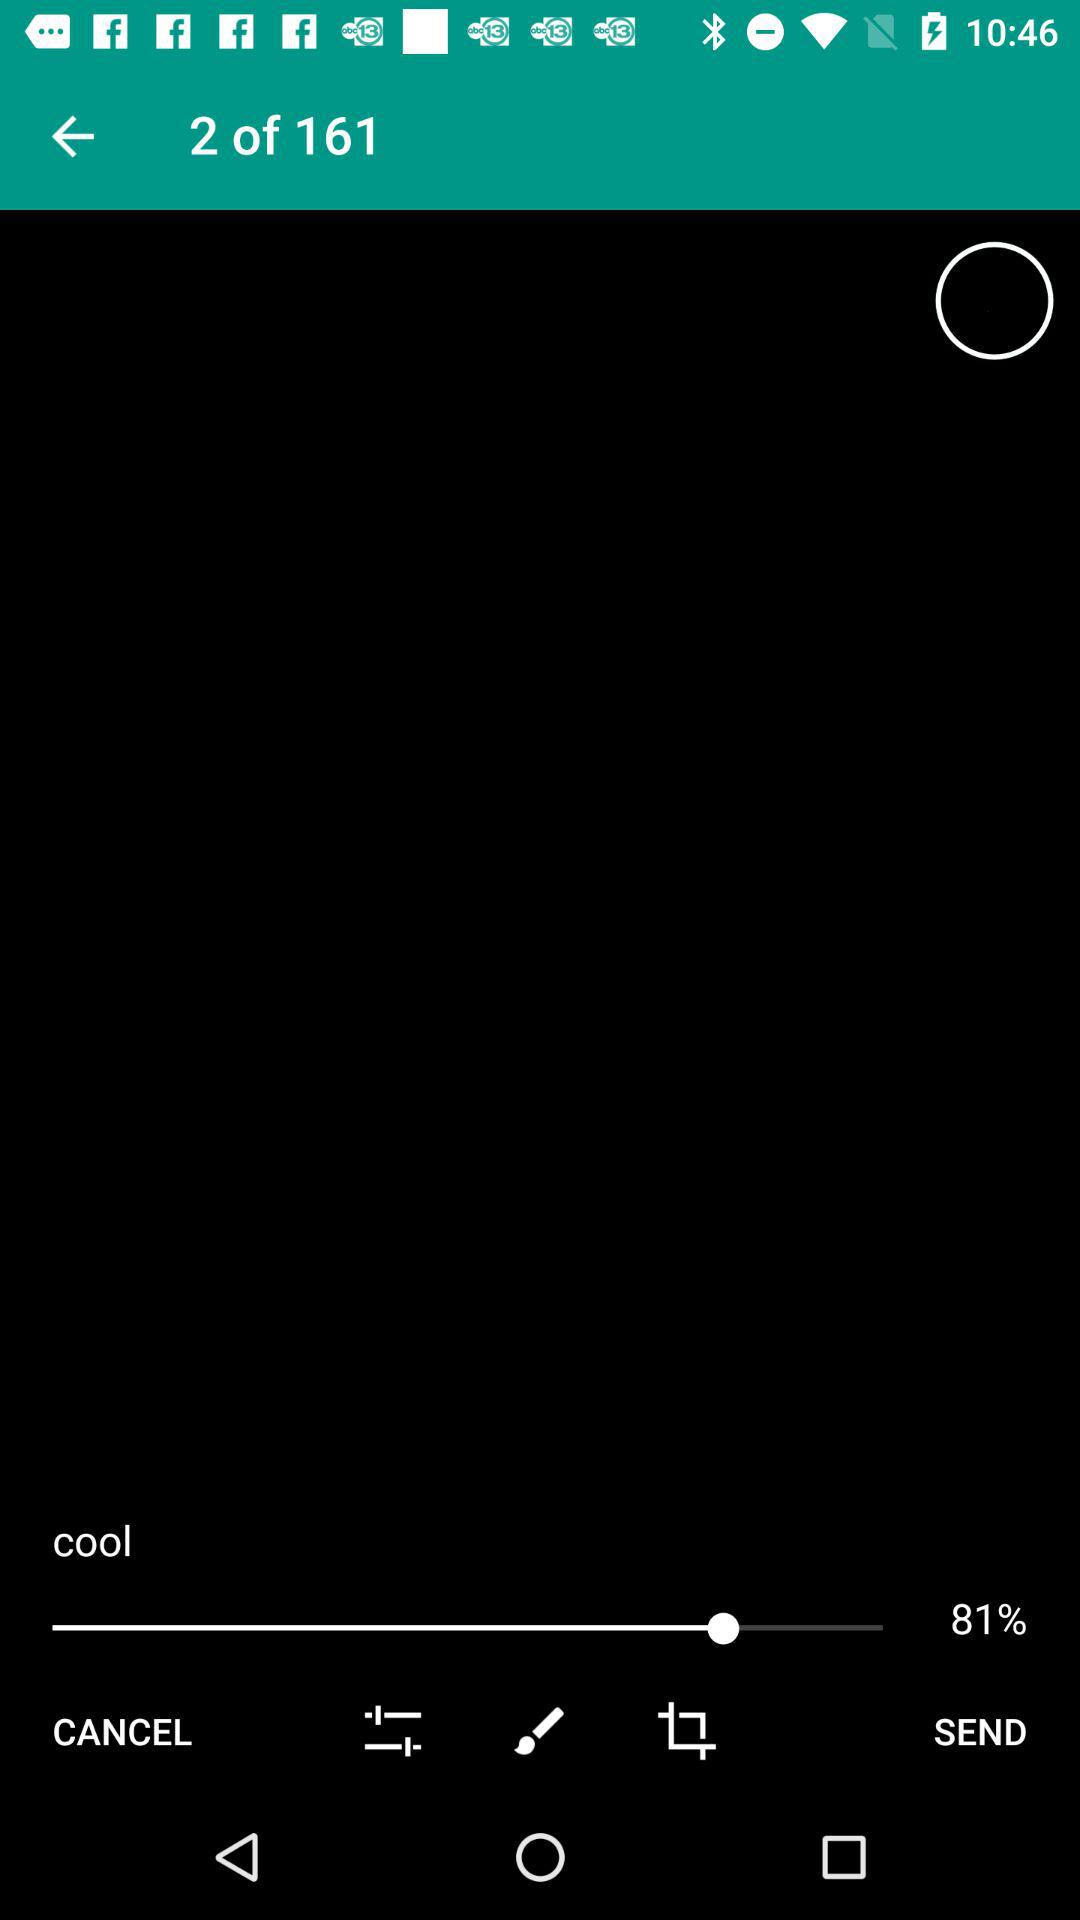What is the percentage of the progress bar?
Answer the question using a single word or phrase. 81% 